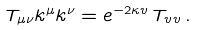<formula> <loc_0><loc_0><loc_500><loc_500>T _ { \mu \nu } k ^ { \mu } k ^ { \nu } = e ^ { - 2 \kappa v } \, T _ { v v } \, .</formula> 